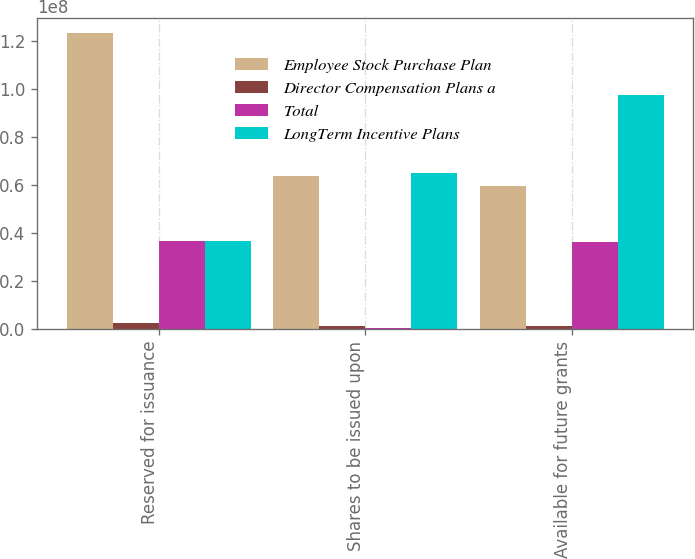Convert chart to OTSL. <chart><loc_0><loc_0><loc_500><loc_500><stacked_bar_chart><ecel><fcel>Reserved for issuance<fcel>Shares to be issued upon<fcel>Available for future grants<nl><fcel>Employee Stock Purchase Plan<fcel>1.23297e+08<fcel>6.37152e+07<fcel>5.95816e+07<nl><fcel>Director Compensation Plans a<fcel>2.34127e+06<fcel>1.02663e+06<fcel>1.31465e+06<nl><fcel>Total<fcel>3.66706e+07<fcel>283400<fcel>3.63872e+07<nl><fcel>LongTerm Incentive Plans<fcel>3.66706e+07<fcel>6.50252e+07<fcel>9.72834e+07<nl></chart> 